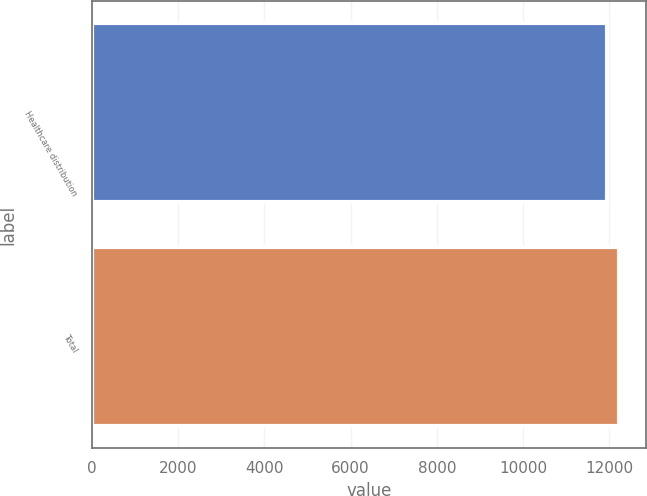<chart> <loc_0><loc_0><loc_500><loc_500><bar_chart><fcel>Healthcare distribution<fcel>Total<nl><fcel>11945<fcel>12239<nl></chart> 